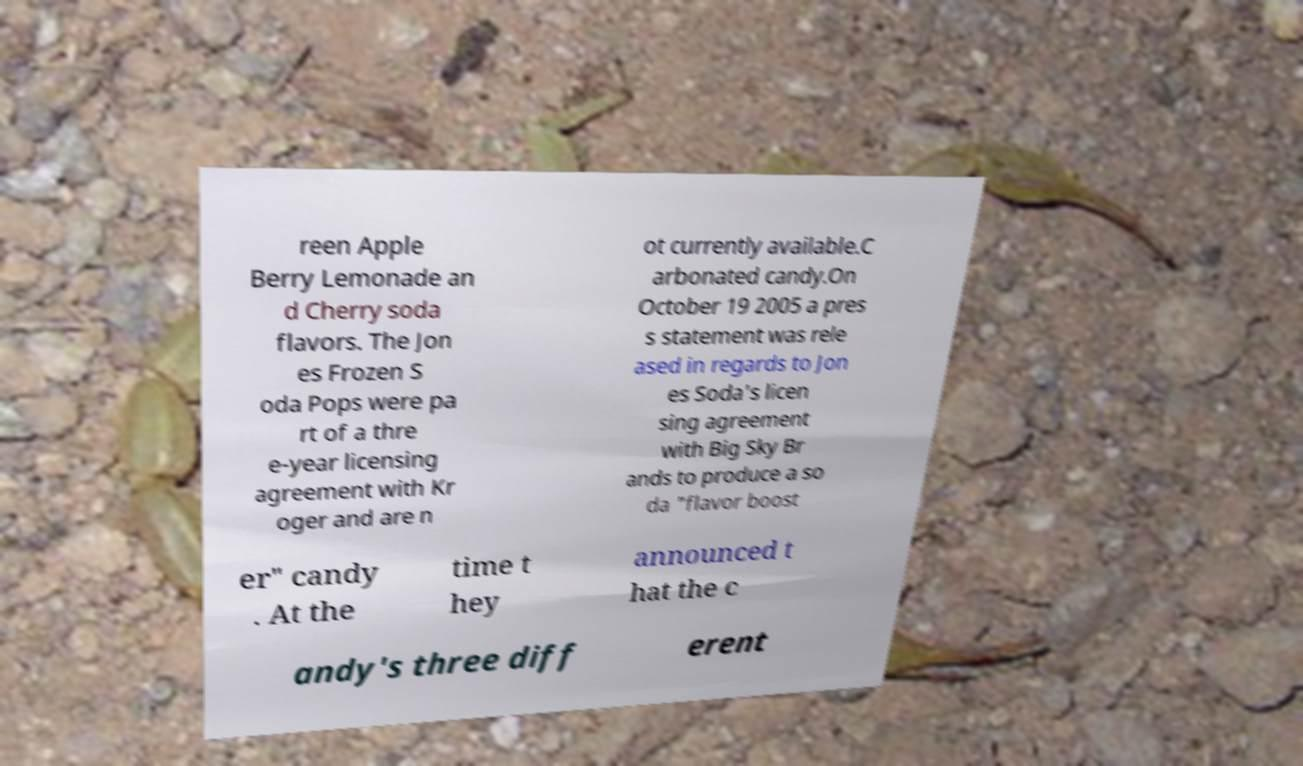Could you assist in decoding the text presented in this image and type it out clearly? reen Apple Berry Lemonade an d Cherry soda flavors. The Jon es Frozen S oda Pops were pa rt of a thre e-year licensing agreement with Kr oger and are n ot currently available.C arbonated candy.On October 19 2005 a pres s statement was rele ased in regards to Jon es Soda's licen sing agreement with Big Sky Br ands to produce a so da "flavor boost er" candy . At the time t hey announced t hat the c andy's three diff erent 